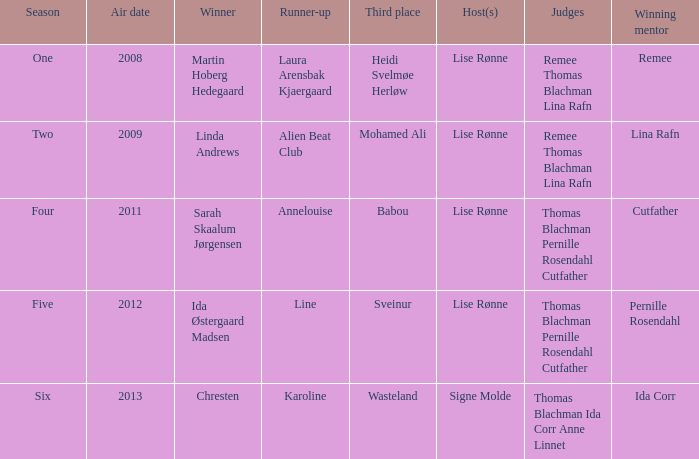Parse the full table. {'header': ['Season', 'Air date', 'Winner', 'Runner-up', 'Third place', 'Host(s)', 'Judges', 'Winning mentor'], 'rows': [['One', '2008', 'Martin Hoberg Hedegaard', 'Laura Arensbak Kjaergaard', 'Heidi Svelmøe Herløw', 'Lise Rønne', 'Remee Thomas Blachman Lina Rafn', 'Remee'], ['Two', '2009', 'Linda Andrews', 'Alien Beat Club', 'Mohamed Ali', 'Lise Rønne', 'Remee Thomas Blachman Lina Rafn', 'Lina Rafn'], ['Four', '2011', 'Sarah Skaalum Jørgensen', 'Annelouise', 'Babou', 'Lise Rønne', 'Thomas Blachman Pernille Rosendahl Cutfather', 'Cutfather'], ['Five', '2012', 'Ida Østergaard Madsen', 'Line', 'Sveinur', 'Lise Rønne', 'Thomas Blachman Pernille Rosendahl Cutfather', 'Pernille Rosendahl'], ['Six', '2013', 'Chresten', 'Karoline', 'Wasteland', 'Signe Molde', 'Thomas Blachman Ida Corr Anne Linnet', 'Ida Corr']]} Who was the finalist that didn't win in season five? Line. 